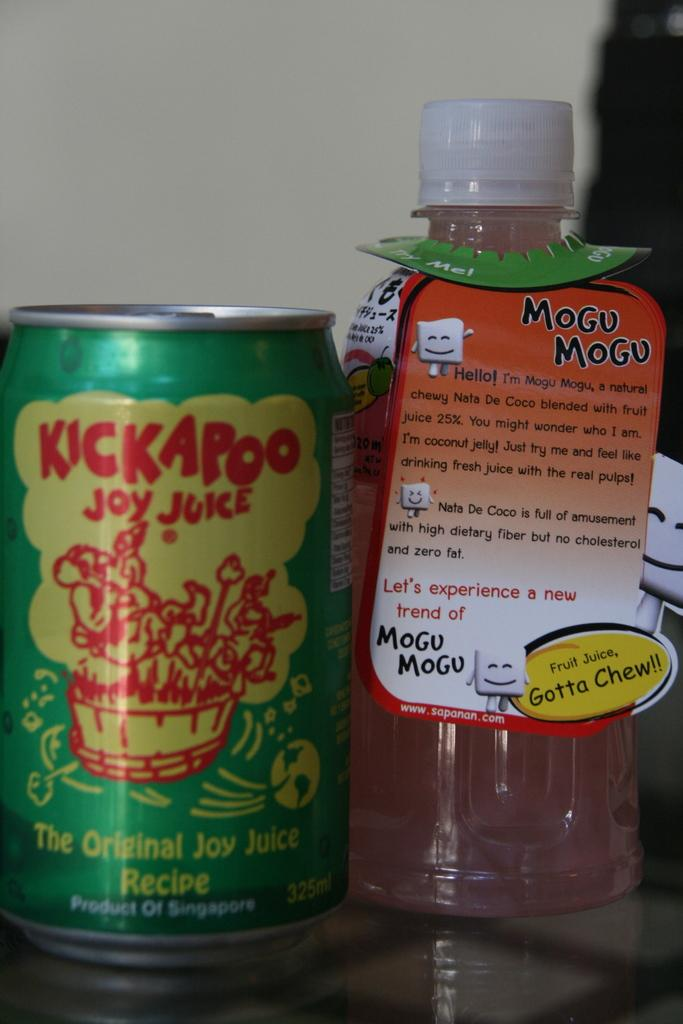<image>
Present a compact description of the photo's key features. A can of Kickapoo Joy Juice is set next to a bottle of coconut water. 